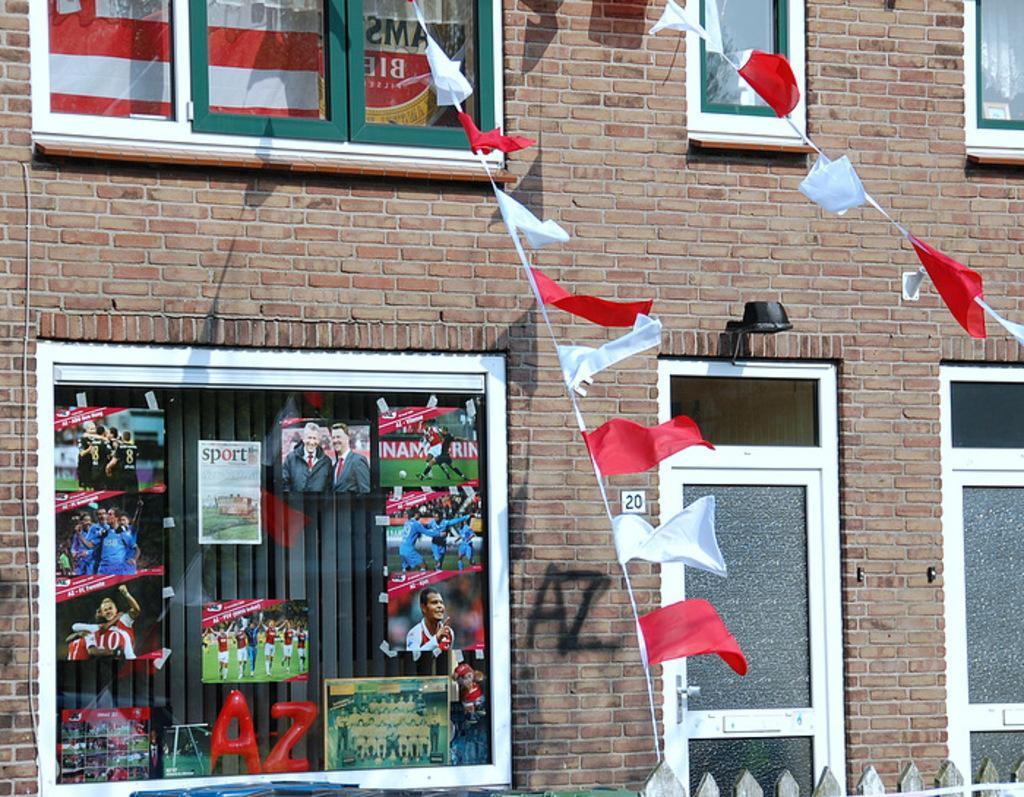In one or two sentences, can you explain what this image depicts? In this image I can see windows to the building. I can see there are many frames and stickers attached to the windows. I can see some red and white color flags in-front of the building. 